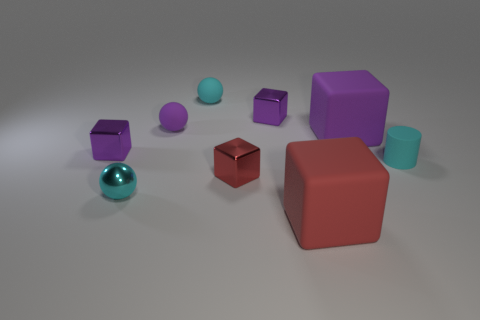Does the tiny cylinder have the same color as the small metal sphere in front of the large purple cube? yes 